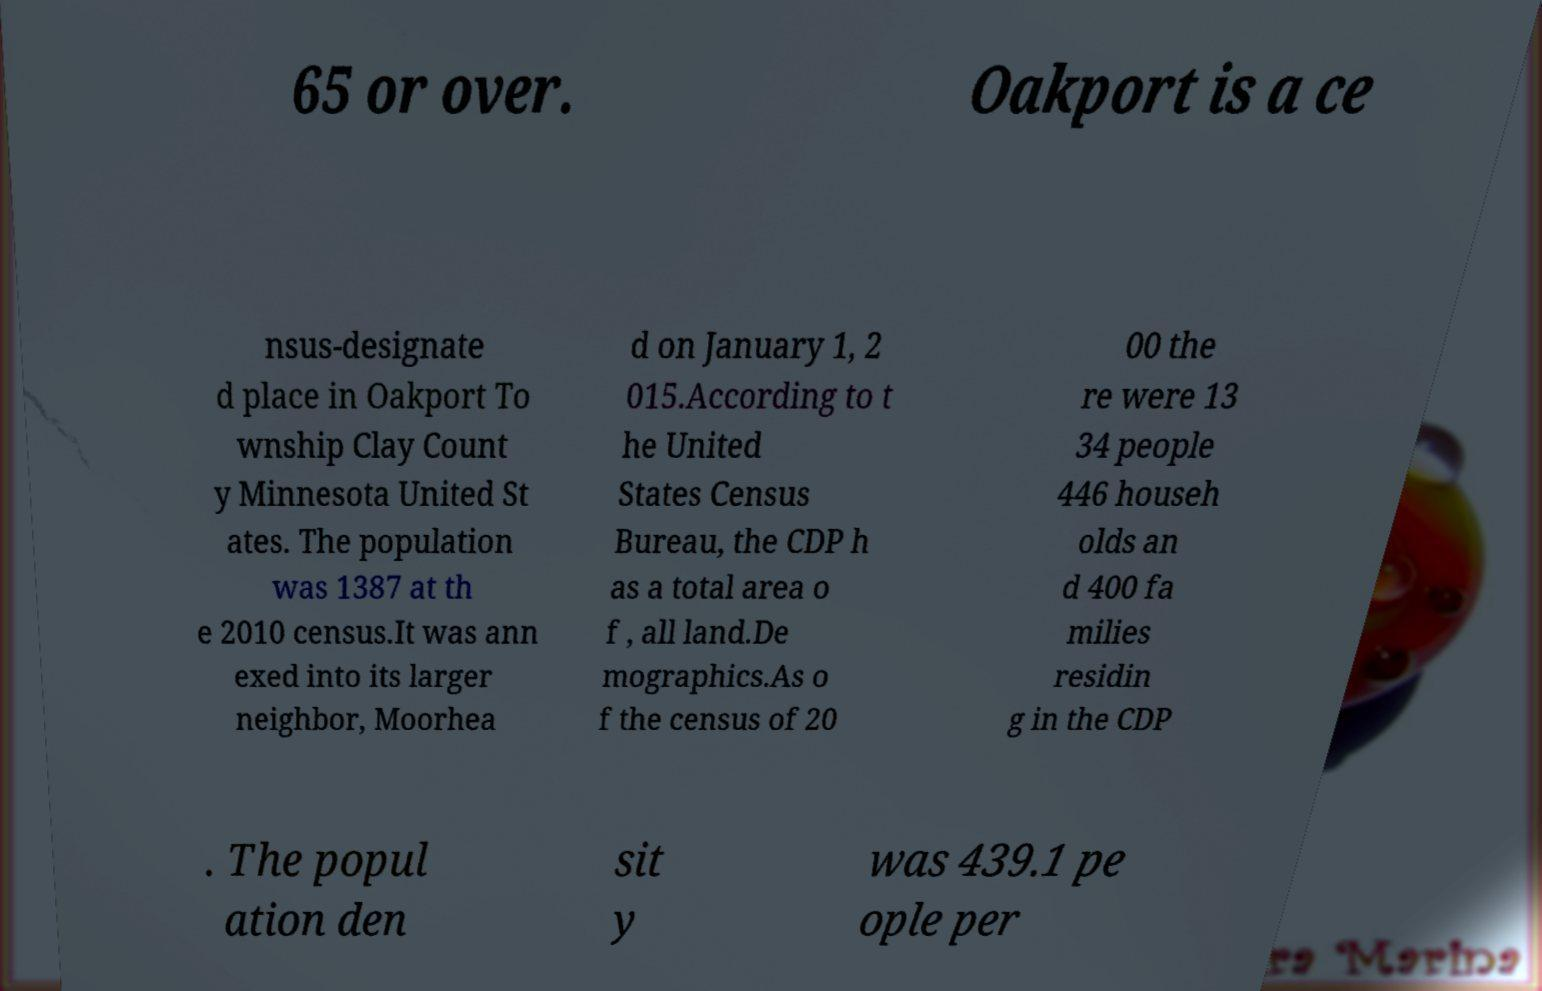There's text embedded in this image that I need extracted. Can you transcribe it verbatim? 65 or over. Oakport is a ce nsus-designate d place in Oakport To wnship Clay Count y Minnesota United St ates. The population was 1387 at th e 2010 census.It was ann exed into its larger neighbor, Moorhea d on January 1, 2 015.According to t he United States Census Bureau, the CDP h as a total area o f , all land.De mographics.As o f the census of 20 00 the re were 13 34 people 446 househ olds an d 400 fa milies residin g in the CDP . The popul ation den sit y was 439.1 pe ople per 